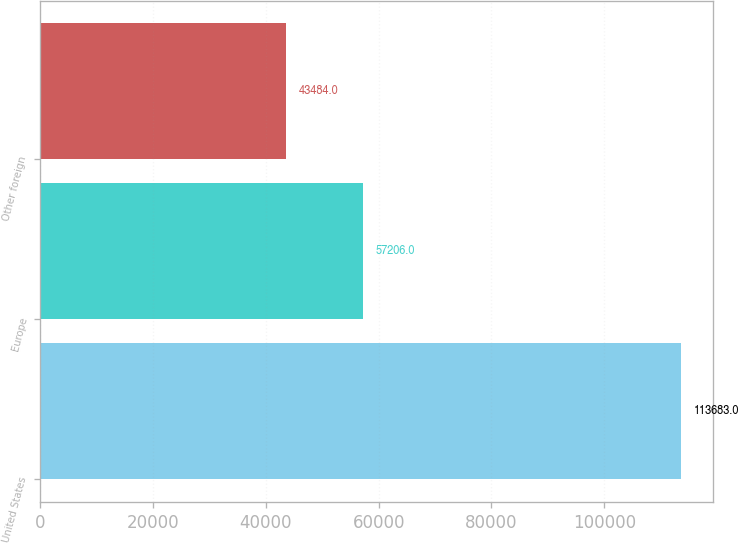Convert chart. <chart><loc_0><loc_0><loc_500><loc_500><bar_chart><fcel>United States<fcel>Europe<fcel>Other foreign<nl><fcel>113683<fcel>57206<fcel>43484<nl></chart> 